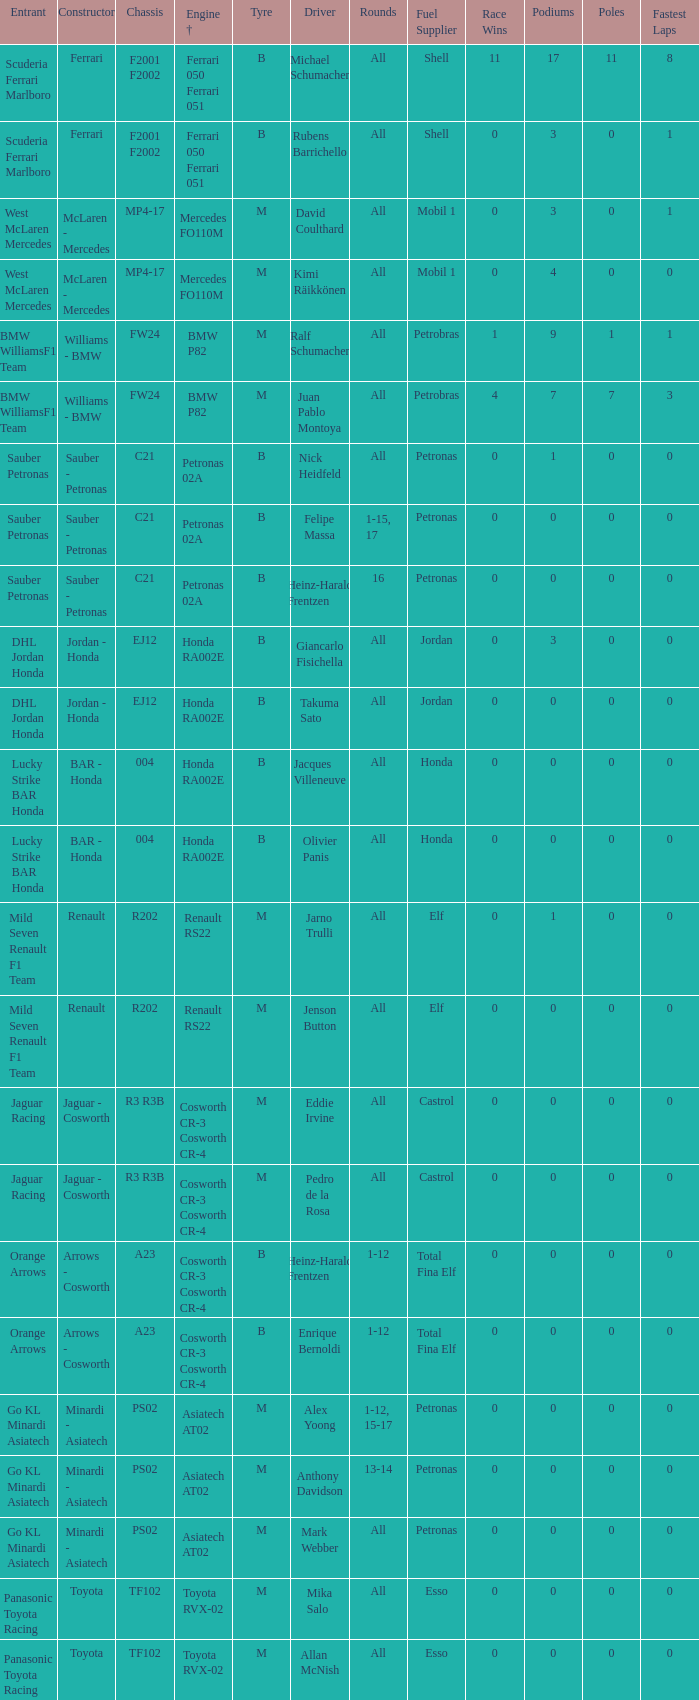What is the rounds when the engine is mercedes fo110m? All, All. 